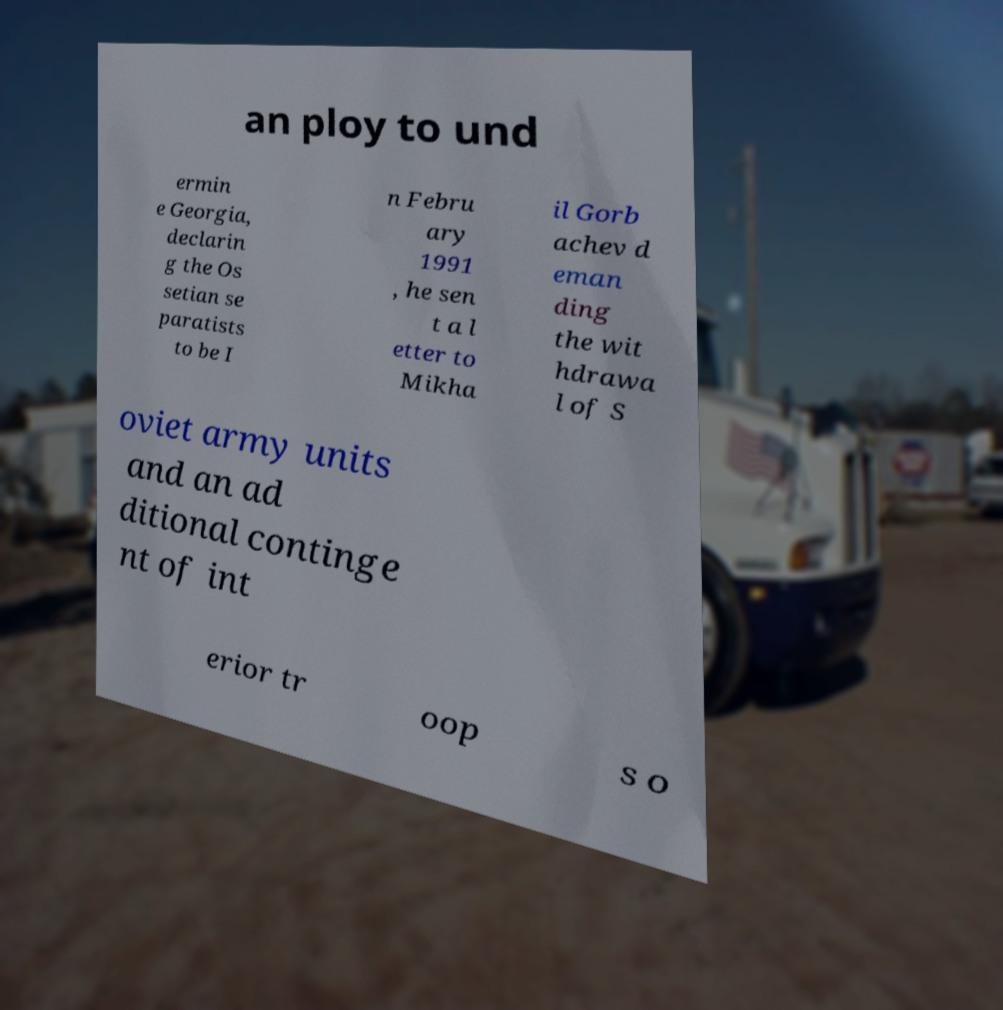Please identify and transcribe the text found in this image. an ploy to und ermin e Georgia, declarin g the Os setian se paratists to be I n Febru ary 1991 , he sen t a l etter to Mikha il Gorb achev d eman ding the wit hdrawa l of S oviet army units and an ad ditional continge nt of int erior tr oop s o 